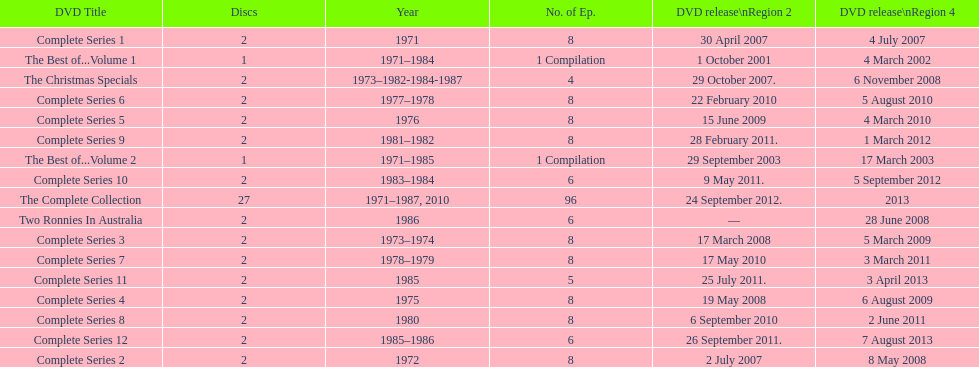Total number of episodes released in region 2 in 2007 20. 